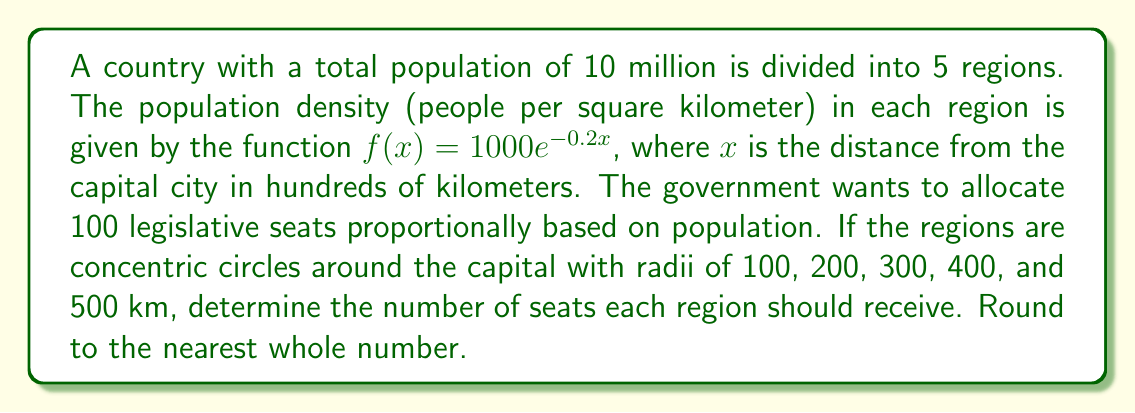Teach me how to tackle this problem. To solve this problem, we need to follow these steps:

1) First, we need to calculate the population of each region. The population of a region is the integral of the population density function over the area of the region.

2) For a circular region, we can use the formula:

   $$P = 2\pi \int_{r_1}^{r_2} rf(r) dr$$

   where $r_1$ and $r_2$ are the inner and outer radii of the region in hundreds of kilometers.

3) Let's calculate the population for each region:

   Region 1 (0-100 km): 
   $$P_1 = 2\pi \int_{0}^{1} r(1000e^{-0.2r}) dr = 2\pi\cdot5000\cdot(1-6e^{-0.2})/0.04 \approx 2,746,801$$

   Region 2 (100-200 km):
   $$P_2 = 2\pi \int_{1}^{2} r(1000e^{-0.2r}) dr \approx 1,673,031$$

   Region 3 (200-300 km):
   $$P_3 = 2\pi \int_{2}^{3} r(1000e^{-0.2r}) dr \approx 1,018,956$$

   Region 4 (300-400 km):
   $$P_4 = 2\pi \int_{3}^{4} r(1000e^{-0.2r}) dr \approx 620,551$$

   Region 5 (400-500 km):
   $$P_5 = 2\pi \int_{4}^{5} r(1000e^{-0.2r}) dr \approx 377,778$$

4) The total population is the sum of these: 6,437,117

5) To allocate seats, we multiply the fraction of total population in each region by 100 and round to the nearest whole number:

   Region 1: $100 \cdot (2,746,801 / 6,437,117) \approx 43$
   Region 2: $100 \cdot (1,673,031 / 6,437,117) \approx 26$
   Region 3: $100 \cdot (1,018,956 / 6,437,117) \approx 16$
   Region 4: $100 \cdot (620,551 / 6,437,117) \approx 10$
   Region 5: $100 \cdot (377,778 / 6,437,117) \approx 6$
Answer: 43, 26, 16, 10, 6 